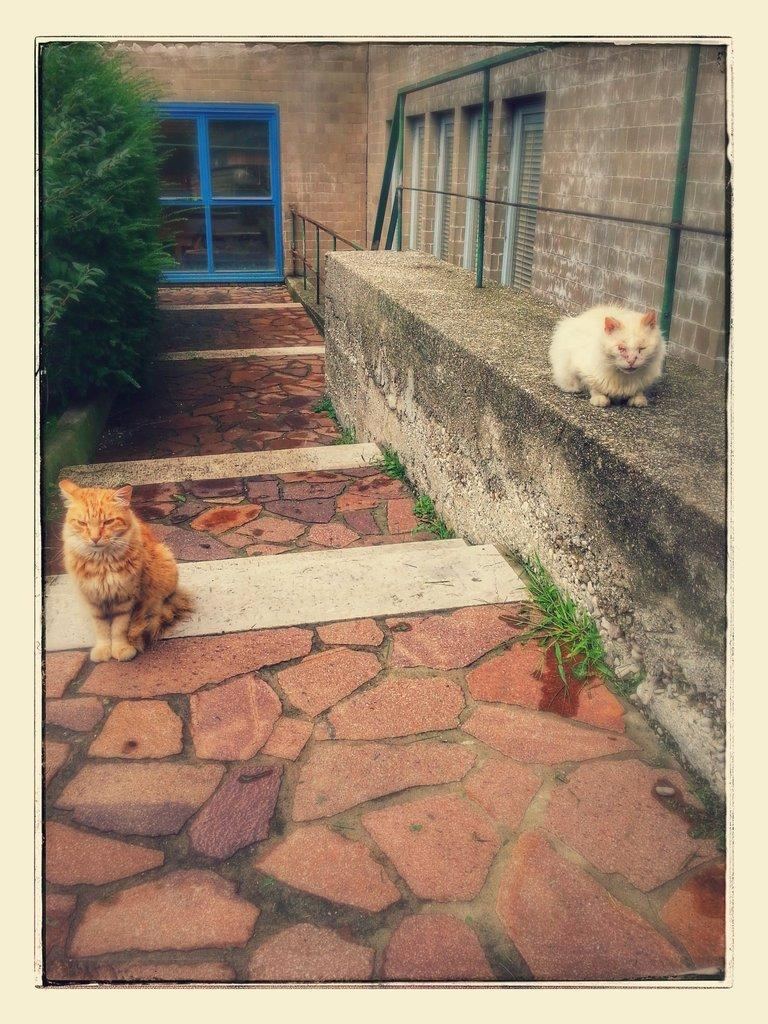What type of animal can be seen on the wall in the image? There is a white cat on a wall in the image. What type of animal can be seen on the path in the image? There is a brown cat on a path in the image. What type of vegetation is visible in the image? There are leaves visible in the image. What type of objects are made of glass in the image? There are glass objects in the image. Can you describe the unspecified things in the image? Unfortunately, the facts provided do not specify what these unspecified things are. What brand of toothpaste is the cat using in the image? There is no toothpaste present in the image, and the cats are not using any toothpaste. What subject is the cat teaching in the image? There is no teaching activity depicted in the image, and the cats are not teaching any subject. 